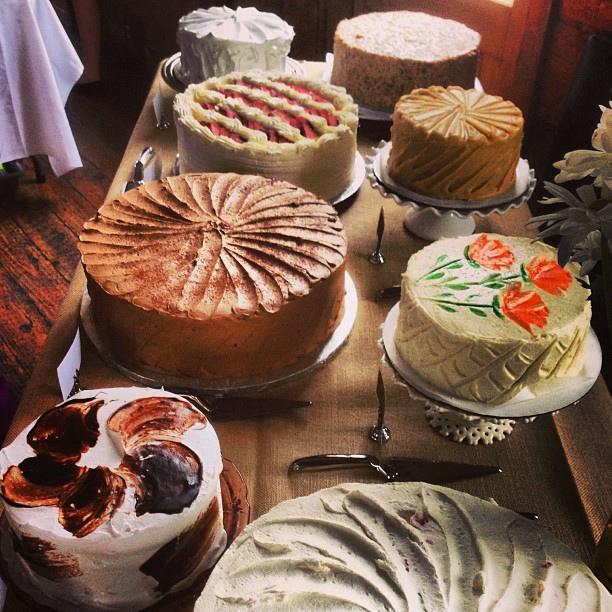How many pieces of cake do you see?
Quick response, please. 8. Is it a good idea to eat all of these in one sitting?
Give a very brief answer. No. Are these healthy foods?
Quick response, please. No. 